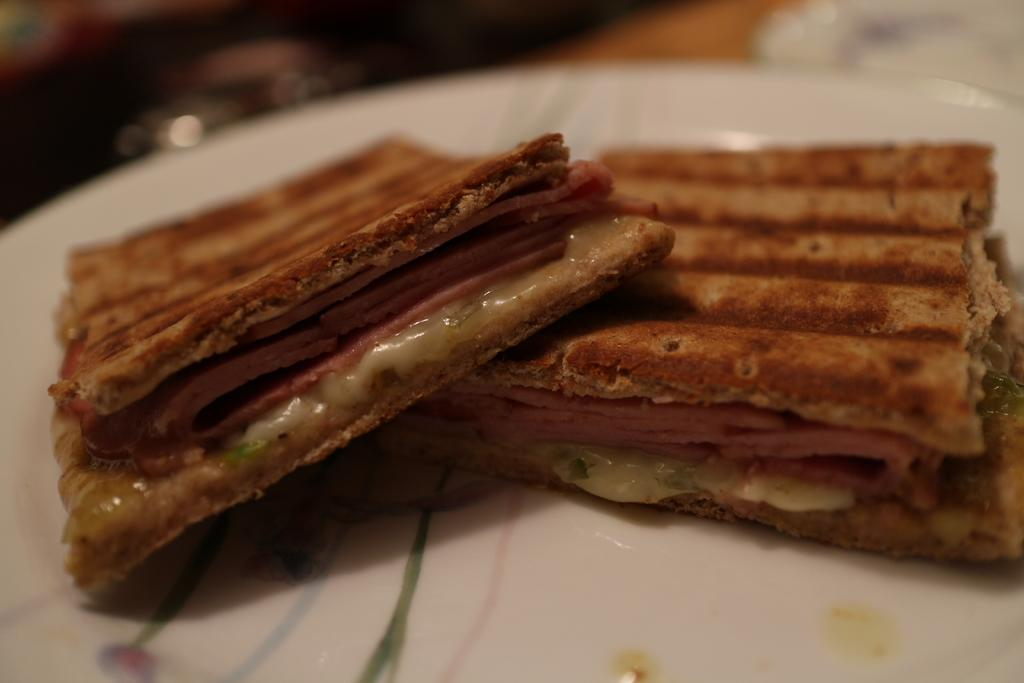What can be seen on the plate in the image? There is a food item on the plate in the image. Can you describe the food item on the plate? Unfortunately, the specific food item cannot be determined from the provided facts. What type of camp can be seen in the background of the image? There is no camp present in the image; it only features a plate with a food item on it. 